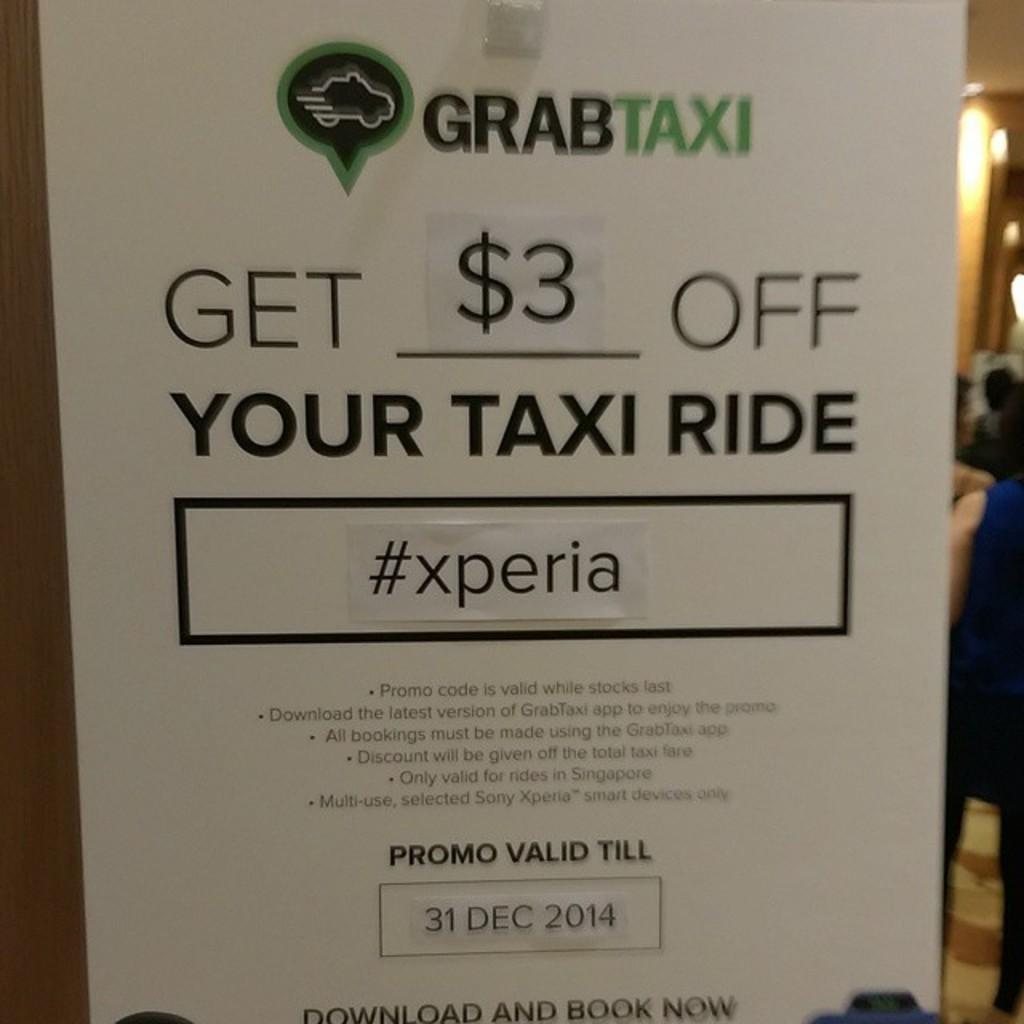Provide a one-sentence caption for the provided image. A posted advertisement for GRABTAXI that states you can get $3 off a taxi ride. 